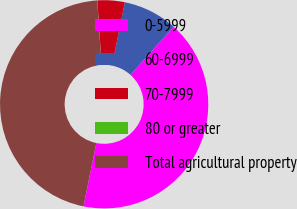Convert chart to OTSL. <chart><loc_0><loc_0><loc_500><loc_500><pie_chart><fcel>0-5999<fcel>60-6999<fcel>70-7999<fcel>80 or greater<fcel>Total agricultural property<nl><fcel>41.55%<fcel>8.44%<fcel>4.23%<fcel>0.02%<fcel>45.76%<nl></chart> 